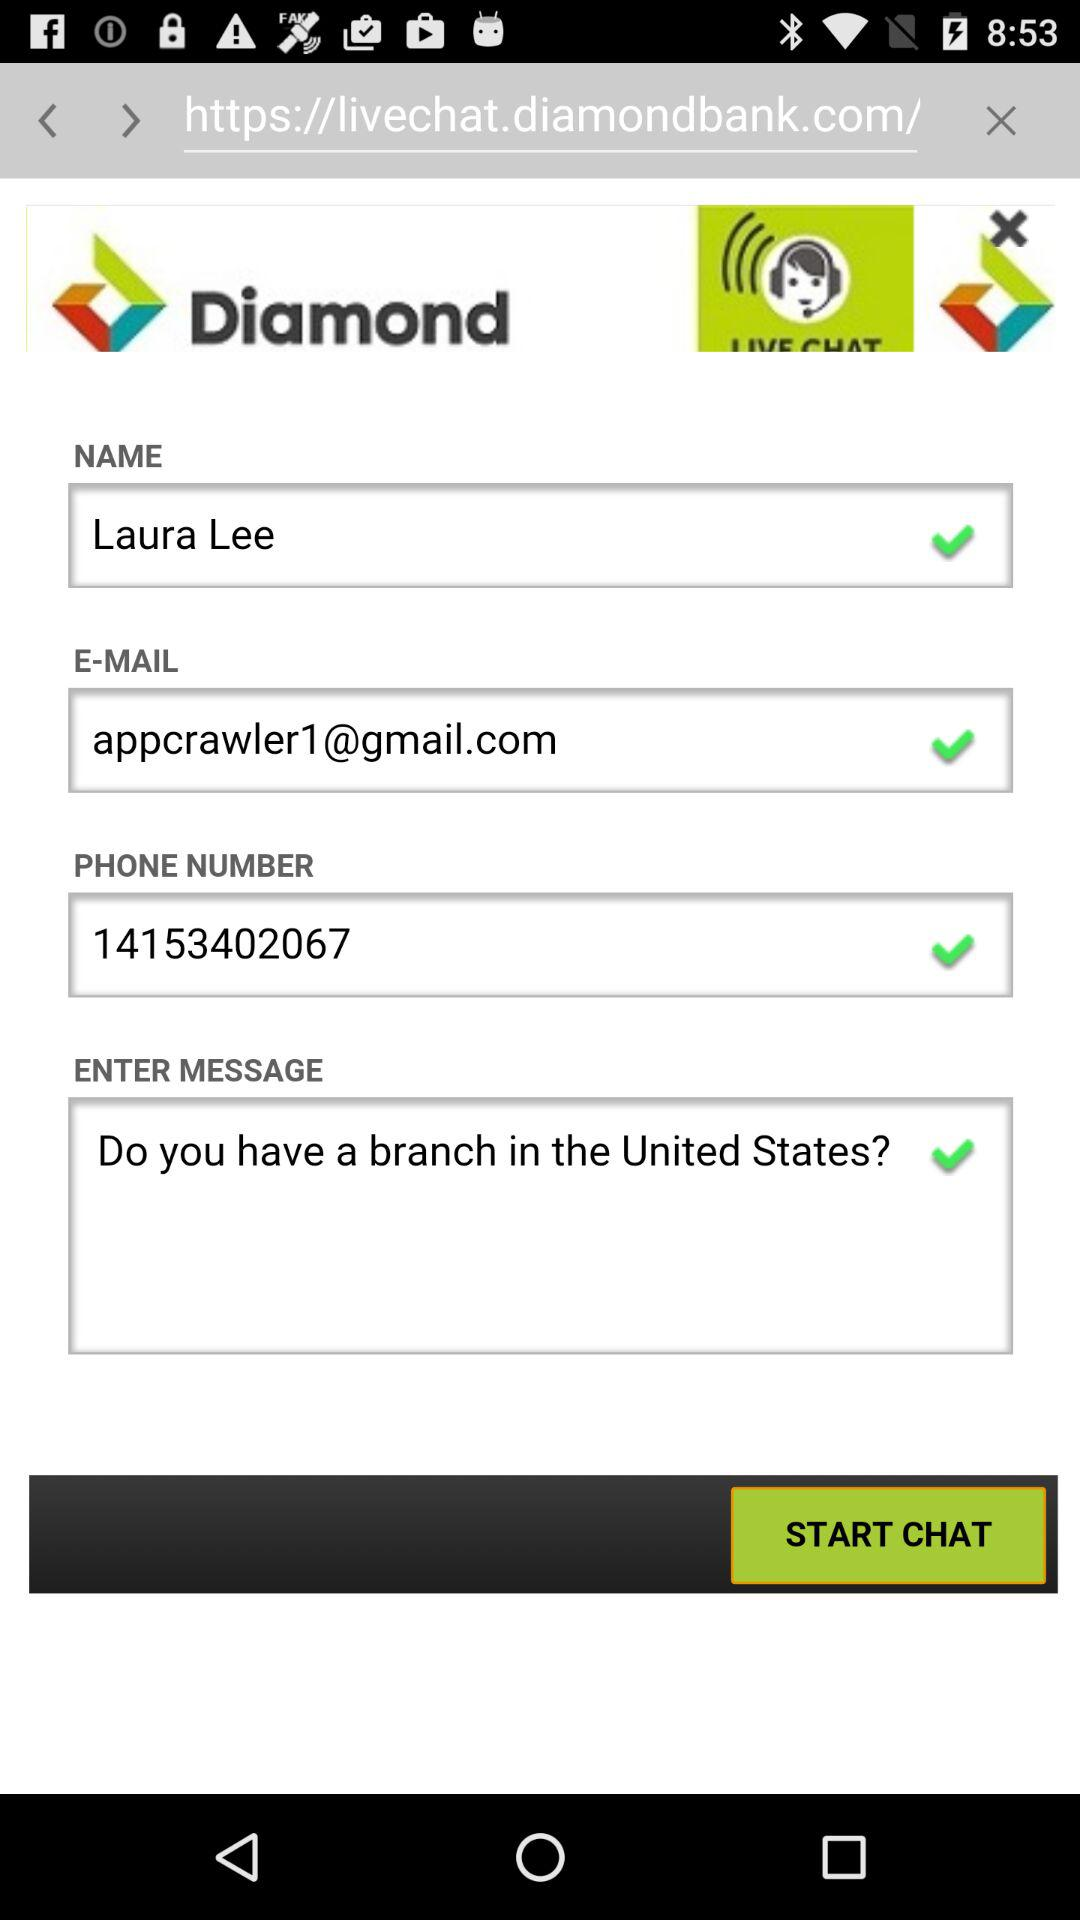What is the email address? The email address is appcrawler1@gmail.com. 